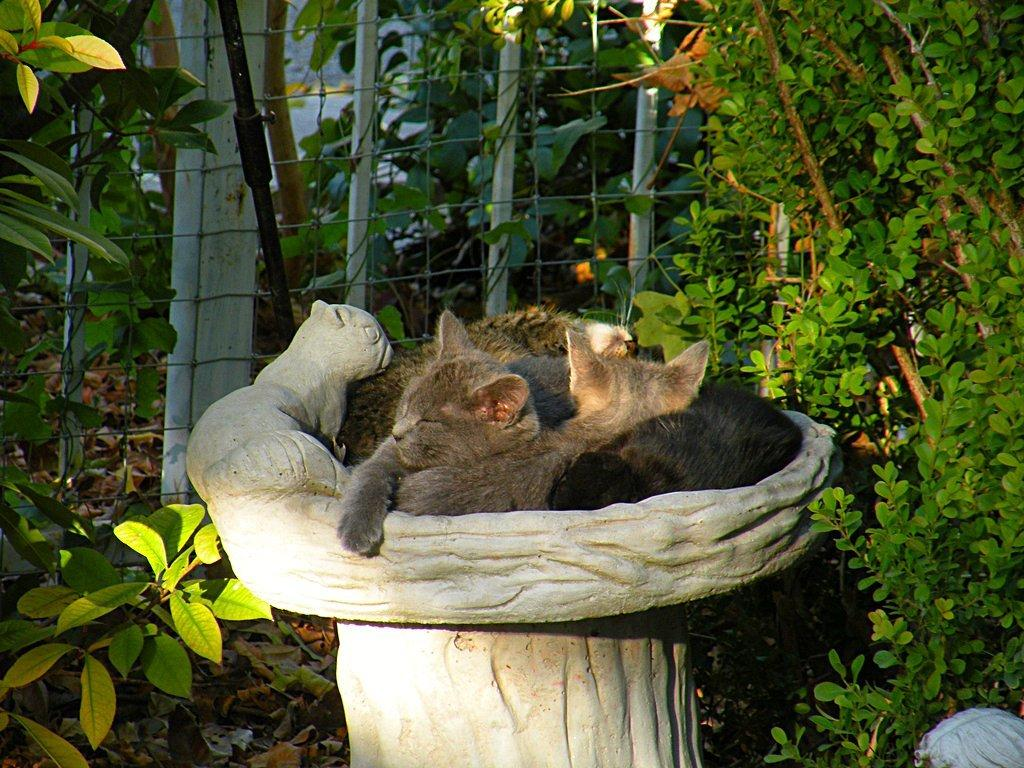What animals are present in the image? There are cats in an object in the image. What type of natural vegetation can be seen in the image? There are trees in the image. What type of barrier is visible in the image? There is a fence in the image. What kind of metal object is present in the image? There is an iron rod in the image. What type of bells can be heard ringing in the image? There are no bells present in the image, and therefore no such sound can be heard. What grade is the cat in the image? The image does not indicate any grade or level for the cats. --- Facts: 1. There is a person holding a book in the image. 2. The person is sitting on a chair. 3. There is a table in the image. 4. There is a lamp on the table. 5. The background of the image is a wall. Absurd Topics: ocean, waves, boat Conversation: What is the person in the image holding? The person in the image is holding a book. What type of furniture is the person sitting on? The person is sitting on a chair. What other piece of furniture is present in the image? There is a table in the image. What object is on the table in the image? There is a lamp on the table. What is visible in the background of the image? The background of the image is a wall. Reasoning: Let's think step by step in order to produce the conversation. We start by identifying the main subject in the image, which is the person holding a book. Then, we expand the conversation to include other elements in the image, such as the chair, table, lamp, and wall. Each question is designed to elicit a specific detail about the image that is known from the provided facts. Absurd Question/Answer: What type of ocean waves can be seen in the image? There are no ocean waves present in the image. Is there a boat visible in the image? There is no boat present in the image. 